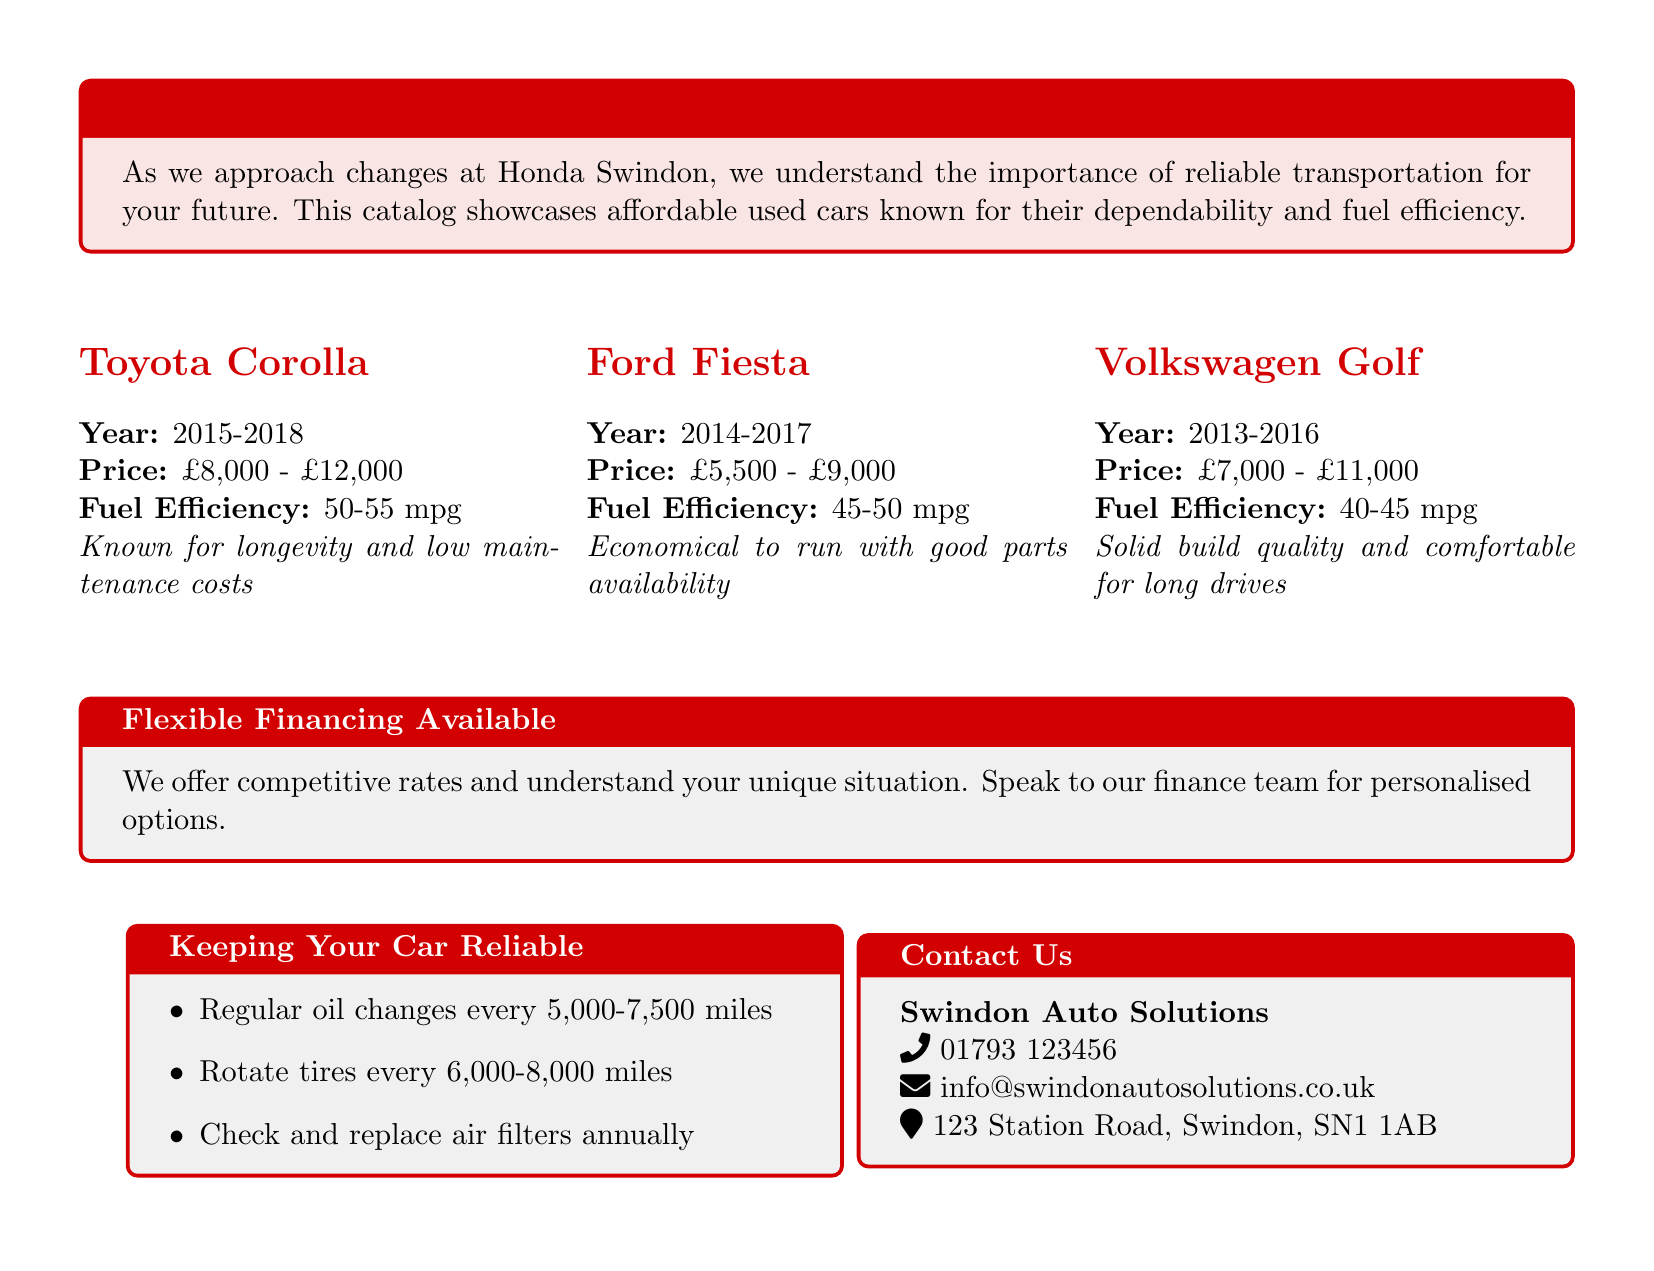what is the price range for a Toyota Corolla? The price range is listed in the document under the Toyota Corolla section, which indicates it is between £8,000 and £12,000.
Answer: £8,000 - £12,000 what is the fuel efficiency of the Ford Fiesta? The document specifies that the Ford Fiesta's fuel efficiency is 45-50 mpg.
Answer: 45-50 mpg which company is offering flexible financing options? The document mentions "Swindon Auto Solutions" as the company providing flexible financing options.
Answer: Swindon Auto Solutions what is the year range for the Volkswagen Golf? The year range for the Volkswagen Golf is stated in the document as 2013-2016.
Answer: 2013-2016 what are the regular oil change intervals? The document advises that regular oil changes should occur every 5,000-7,500 miles.
Answer: every 5,000-7,500 miles why might someone choose a Toyota Corolla? The Toyota Corolla is described as known for longevity and low maintenance costs, making it a trusted choice.
Answer: longevity and low maintenance costs how can customers contact Swindon Auto Solutions? The contact information for Swindon Auto Solutions is included in the document detailing a phone number, email, and address.
Answer: 01793 123456, info@swindonautosolutions.co.uk, 123 Station Road, Swindon, SN1 1AB what type of cars does this catalog highlight? The catalog highlights affordable used cars that are recognized for their reliability and fuel efficiency.
Answer: affordable used cars what maintenance task should be done annually? The document recommends checking and replacing air filters annually as part of the car maintenance.
Answer: replace air filters annually 